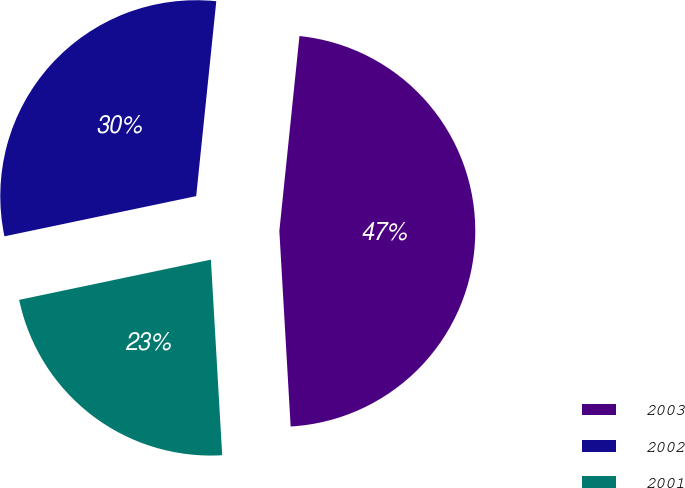Convert chart. <chart><loc_0><loc_0><loc_500><loc_500><pie_chart><fcel>2003<fcel>2002<fcel>2001<nl><fcel>47.45%<fcel>29.93%<fcel>22.63%<nl></chart> 